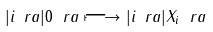<formula> <loc_0><loc_0><loc_500><loc_500>| i \ r a | 0 \ r a \longmapsto | i \ r a | X _ { i } \ r a</formula> 